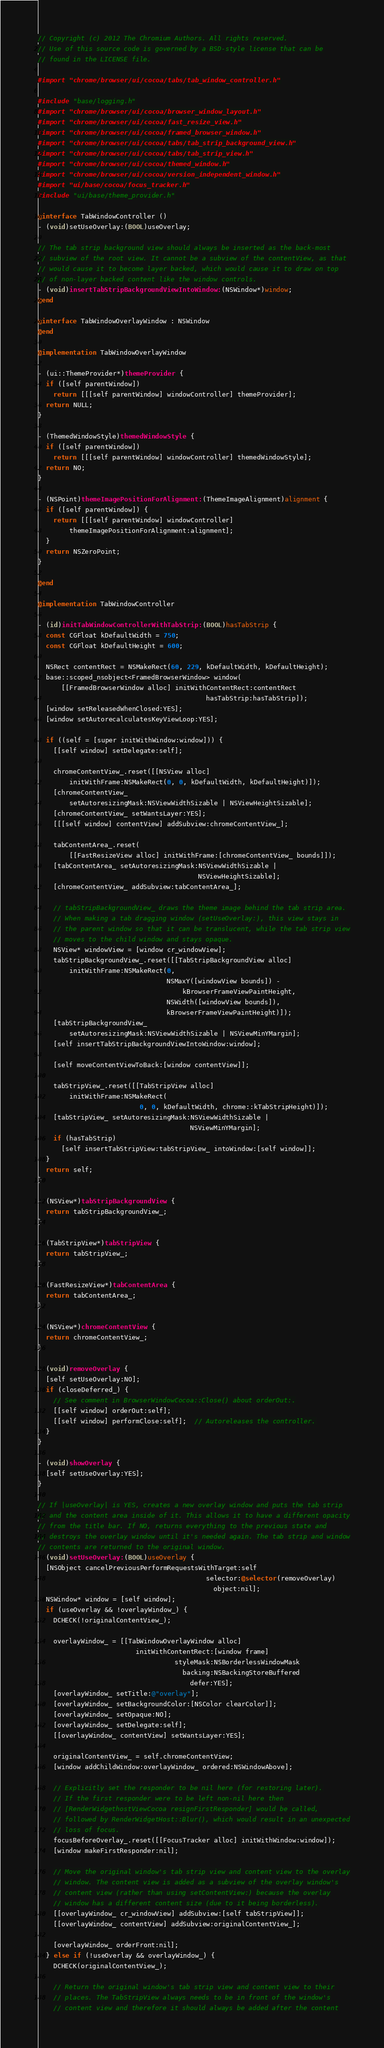<code> <loc_0><loc_0><loc_500><loc_500><_ObjectiveC_>// Copyright (c) 2012 The Chromium Authors. All rights reserved.
// Use of this source code is governed by a BSD-style license that can be
// found in the LICENSE file.

#import "chrome/browser/ui/cocoa/tabs/tab_window_controller.h"

#include "base/logging.h"
#import "chrome/browser/ui/cocoa/browser_window_layout.h"
#import "chrome/browser/ui/cocoa/fast_resize_view.h"
#import "chrome/browser/ui/cocoa/framed_browser_window.h"
#import "chrome/browser/ui/cocoa/tabs/tab_strip_background_view.h"
#import "chrome/browser/ui/cocoa/tabs/tab_strip_view.h"
#import "chrome/browser/ui/cocoa/themed_window.h"
#import "chrome/browser/ui/cocoa/version_independent_window.h"
#import "ui/base/cocoa/focus_tracker.h"
#include "ui/base/theme_provider.h"

@interface TabWindowController ()
- (void)setUseOverlay:(BOOL)useOverlay;

// The tab strip background view should always be inserted as the back-most
// subview of the root view. It cannot be a subview of the contentView, as that
// would cause it to become layer backed, which would cause it to draw on top
// of non-layer backed content like the window controls.
- (void)insertTabStripBackgroundViewIntoWindow:(NSWindow*)window;
@end

@interface TabWindowOverlayWindow : NSWindow
@end

@implementation TabWindowOverlayWindow

- (ui::ThemeProvider*)themeProvider {
  if ([self parentWindow])
    return [[[self parentWindow] windowController] themeProvider];
  return NULL;
}

- (ThemedWindowStyle)themedWindowStyle {
  if ([self parentWindow])
    return [[[self parentWindow] windowController] themedWindowStyle];
  return NO;
}

- (NSPoint)themeImagePositionForAlignment:(ThemeImageAlignment)alignment {
  if ([self parentWindow]) {
    return [[[self parentWindow] windowController]
        themeImagePositionForAlignment:alignment];
  }
  return NSZeroPoint;
}

@end

@implementation TabWindowController

- (id)initTabWindowControllerWithTabStrip:(BOOL)hasTabStrip {
  const CGFloat kDefaultWidth = 750;
  const CGFloat kDefaultHeight = 600;

  NSRect contentRect = NSMakeRect(60, 229, kDefaultWidth, kDefaultHeight);
  base::scoped_nsobject<FramedBrowserWindow> window(
      [[FramedBrowserWindow alloc] initWithContentRect:contentRect
                                           hasTabStrip:hasTabStrip]);
  [window setReleasedWhenClosed:YES];
  [window setAutorecalculatesKeyViewLoop:YES];

  if ((self = [super initWithWindow:window])) {
    [[self window] setDelegate:self];

    chromeContentView_.reset([[NSView alloc]
        initWithFrame:NSMakeRect(0, 0, kDefaultWidth, kDefaultHeight)]);
    [chromeContentView_
        setAutoresizingMask:NSViewWidthSizable | NSViewHeightSizable];
    [chromeContentView_ setWantsLayer:YES];
    [[[self window] contentView] addSubview:chromeContentView_];

    tabContentArea_.reset(
        [[FastResizeView alloc] initWithFrame:[chromeContentView_ bounds]]);
    [tabContentArea_ setAutoresizingMask:NSViewWidthSizable |
                                         NSViewHeightSizable];
    [chromeContentView_ addSubview:tabContentArea_];

    // tabStripBackgroundView_ draws the theme image behind the tab strip area.
    // When making a tab dragging window (setUseOverlay:), this view stays in
    // the parent window so that it can be translucent, while the tab strip view
    // moves to the child window and stays opaque.
    NSView* windowView = [window cr_windowView];
    tabStripBackgroundView_.reset([[TabStripBackgroundView alloc]
        initWithFrame:NSMakeRect(0,
                                 NSMaxY([windowView bounds]) -
                                     kBrowserFrameViewPaintHeight,
                                 NSWidth([windowView bounds]),
                                 kBrowserFrameViewPaintHeight)]);
    [tabStripBackgroundView_
        setAutoresizingMask:NSViewWidthSizable | NSViewMinYMargin];
    [self insertTabStripBackgroundViewIntoWindow:window];

    [self moveContentViewToBack:[window contentView]];

    tabStripView_.reset([[TabStripView alloc]
        initWithFrame:NSMakeRect(
                          0, 0, kDefaultWidth, chrome::kTabStripHeight)]);
    [tabStripView_ setAutoresizingMask:NSViewWidthSizable |
                                       NSViewMinYMargin];
    if (hasTabStrip)
      [self insertTabStripView:tabStripView_ intoWindow:[self window]];
  }
  return self;
}

- (NSView*)tabStripBackgroundView {
  return tabStripBackgroundView_;
}

- (TabStripView*)tabStripView {
  return tabStripView_;
}

- (FastResizeView*)tabContentArea {
  return tabContentArea_;
}

- (NSView*)chromeContentView {
  return chromeContentView_;
}

- (void)removeOverlay {
  [self setUseOverlay:NO];
  if (closeDeferred_) {
    // See comment in BrowserWindowCocoa::Close() about orderOut:.
    [[self window] orderOut:self];
    [[self window] performClose:self];  // Autoreleases the controller.
  }
}

- (void)showOverlay {
  [self setUseOverlay:YES];
}

// If |useOverlay| is YES, creates a new overlay window and puts the tab strip
// and the content area inside of it. This allows it to have a different opacity
// from the title bar. If NO, returns everything to the previous state and
// destroys the overlay window until it's needed again. The tab strip and window
// contents are returned to the original window.
- (void)setUseOverlay:(BOOL)useOverlay {
  [NSObject cancelPreviousPerformRequestsWithTarget:self
                                           selector:@selector(removeOverlay)
                                             object:nil];
  NSWindow* window = [self window];
  if (useOverlay && !overlayWindow_) {
    DCHECK(!originalContentView_);

    overlayWindow_ = [[TabWindowOverlayWindow alloc]
                         initWithContentRect:[window frame]
                                   styleMask:NSBorderlessWindowMask
                                     backing:NSBackingStoreBuffered
                                       defer:YES];
    [overlayWindow_ setTitle:@"overlay"];
    [overlayWindow_ setBackgroundColor:[NSColor clearColor]];
    [overlayWindow_ setOpaque:NO];
    [overlayWindow_ setDelegate:self];
    [[overlayWindow_ contentView] setWantsLayer:YES];

    originalContentView_ = self.chromeContentView;
    [window addChildWindow:overlayWindow_ ordered:NSWindowAbove];

    // Explicitly set the responder to be nil here (for restoring later).
    // If the first responder were to be left non-nil here then
    // [RenderWidgethostViewCocoa resignFirstResponder] would be called,
    // followed by RenderWidgetHost::Blur(), which would result in an unexpected
    // loss of focus.
    focusBeforeOverlay_.reset([[FocusTracker alloc] initWithWindow:window]);
    [window makeFirstResponder:nil];

    // Move the original window's tab strip view and content view to the overlay
    // window. The content view is added as a subview of the overlay window's
    // content view (rather than using setContentView:) because the overlay
    // window has a different content size (due to it being borderless).
    [[overlayWindow_ cr_windowView] addSubview:[self tabStripView]];
    [[overlayWindow_ contentView] addSubview:originalContentView_];

    [overlayWindow_ orderFront:nil];
  } else if (!useOverlay && overlayWindow_) {
    DCHECK(originalContentView_);

    // Return the original window's tab strip view and content view to their
    // places. The TabStripView always needs to be in front of the window's
    // content view and therefore it should always be added after the content</code> 